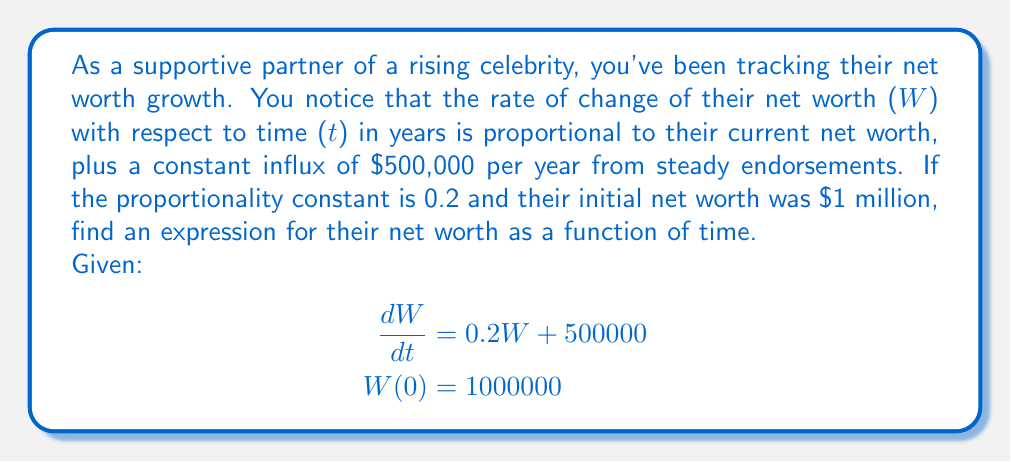Give your solution to this math problem. To solve this first-order linear differential equation, we'll follow these steps:

1) The general form of the equation is:
   $$\frac{dW}{dt} + P(t)W = Q(t)$$
   where $P(t) = -0.2$ and $Q(t) = 500000$

2) Find the integrating factor:
   $$\mu(t) = e^{\int P(t)dt} = e^{\int -0.2dt} = e^{-0.2t}$$

3) Multiply both sides of the original equation by the integrating factor:
   $$e^{-0.2t}\frac{dW}{dt} + 0.2e^{-0.2t}W = 500000e^{-0.2t}$$

4) The left side is now the derivative of $e^{-0.2t}W$:
   $$\frac{d}{dt}(e^{-0.2t}W) = 500000e^{-0.2t}$$

5) Integrate both sides:
   $$e^{-0.2t}W = -2500000e^{-0.2t} + C$$

6) Solve for W:
   $$W = -2500000 + Ce^{0.2t}$$

7) Use the initial condition $W(0) = 1000000$ to find C:
   $$1000000 = -2500000 + C$$
   $$C = 3500000$$

8) The final solution is:
   $$W(t) = -2500000 + 3500000e^{0.2t}$$
Answer: $$W(t) = -2500000 + 3500000e^{0.2t}$$ 